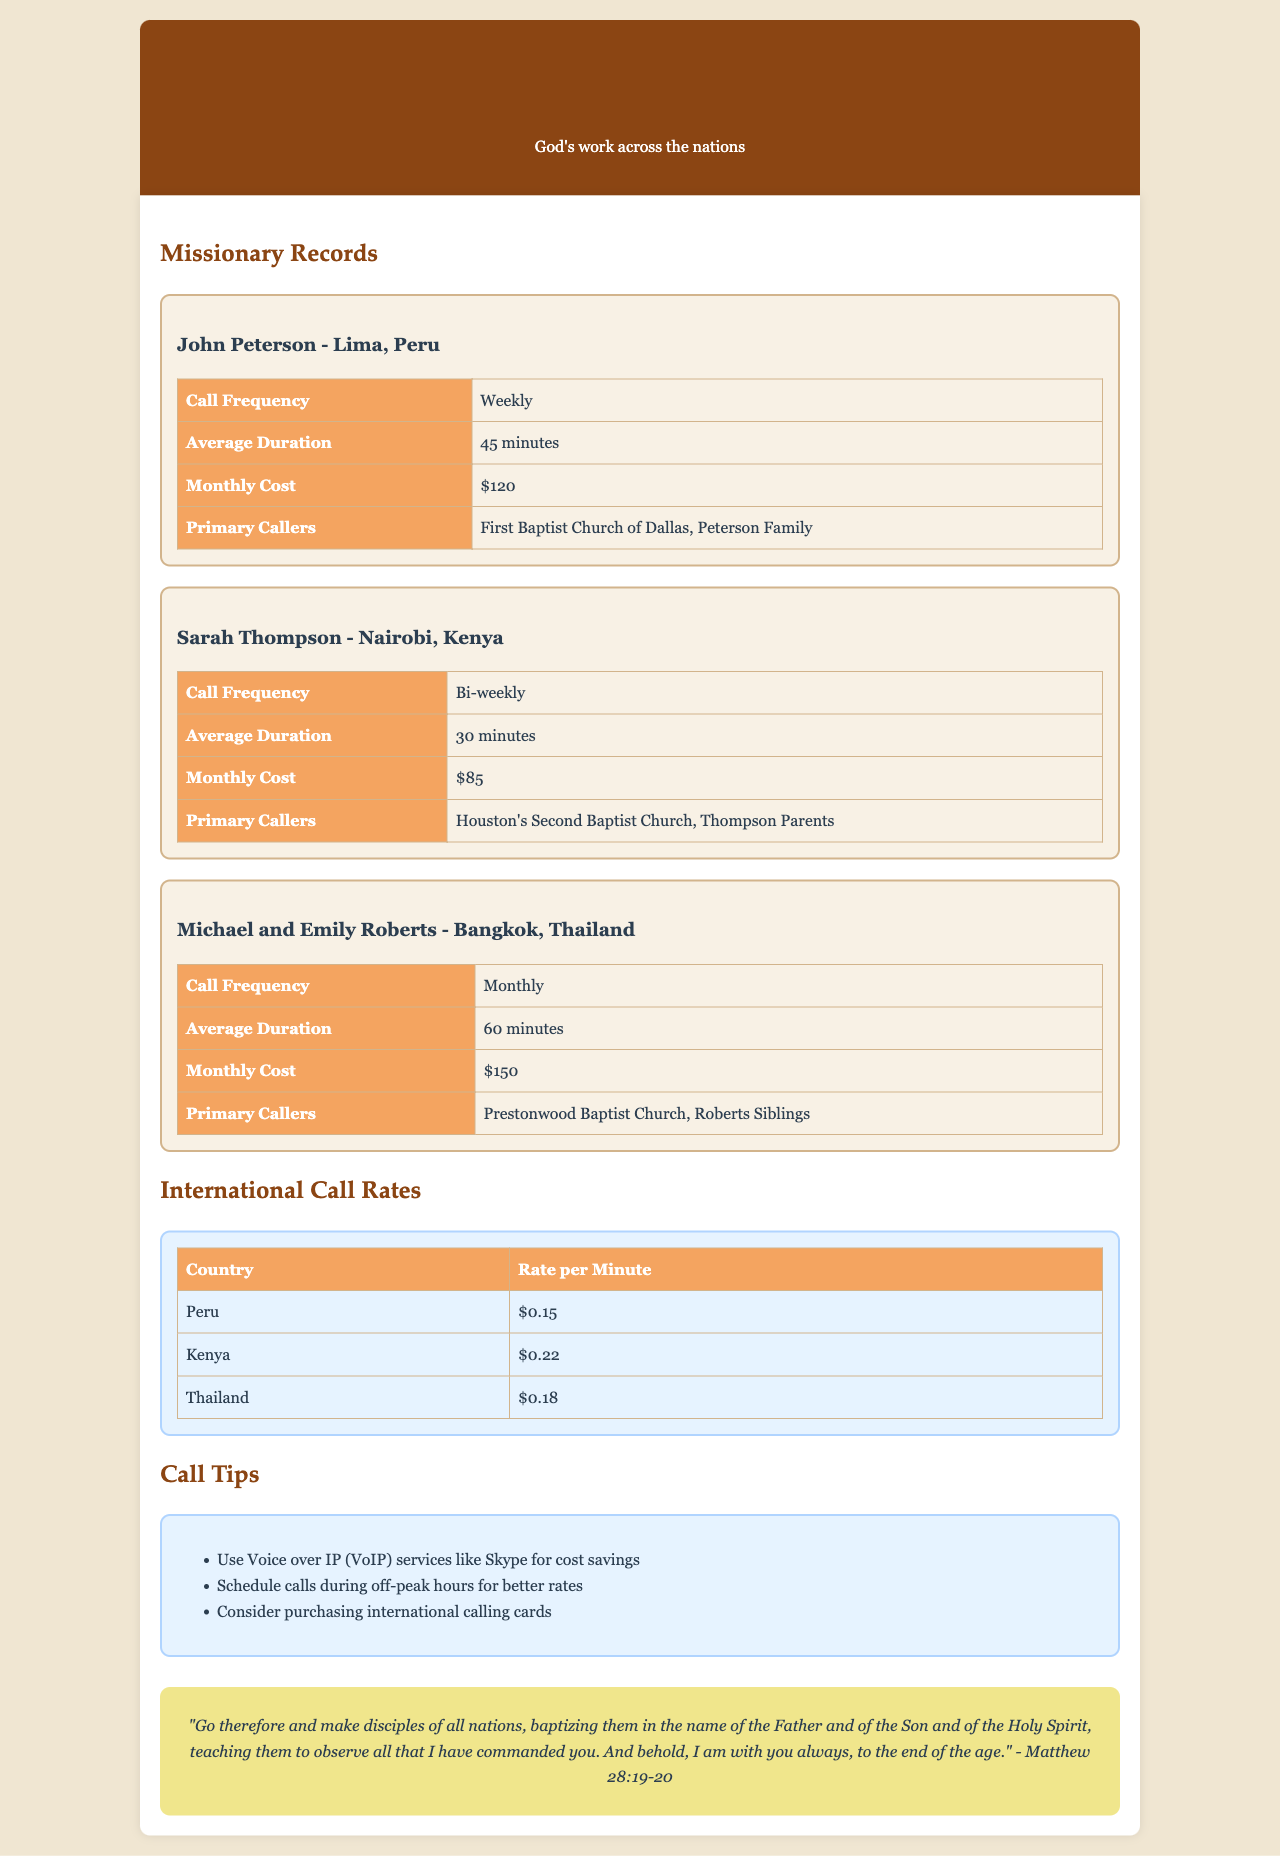What is the average duration of calls to John Peterson? The average duration is provided in the record for John Peterson which states "45 minutes."
Answer: 45 minutes How much does it cost monthly to call Sarah Thompson? The monthly cost for calling Sarah Thompson is specified as "$85."
Answer: $85 What is the rate per minute for calls to Thailand? The document lists the rate per minute for calls to Thailand as "$0.18."
Answer: $0.18 How frequently are calls made to Michael and Emily Roberts? The frequency of calls made to Michael and Emily Roberts is stated as "Monthly."
Answer: Monthly Which church primarily calls John Peterson? The primary callers for John Peterson are identified as "First Baptist Church of Dallas."
Answer: First Baptist Church of Dallas If one were to call Peru for an hour, what would the cost be? The cost to call Peru for an hour (60 minutes) is calculated as 60 minutes multiplied by $0.15 per minute which amounts to "$9."
Answer: $9 How many minutes is the average call to Sarah Thompson? The average duration for calls to Sarah Thompson is "30 minutes" as per the record.
Answer: 30 minutes What suggestion is made for saving costs on calls? The document suggests using "Voice over IP (VoIP) services like Skype" for cost savings.
Answer: Voice over IP (VoIP) services like Skype How many primary callers does Michael and Emily Roberts have? The primary callers for Michael and Emily Roberts are "Prestonwood Baptist Church, Roberts Siblings," which indicates there are multiple callers.
Answer: Two 